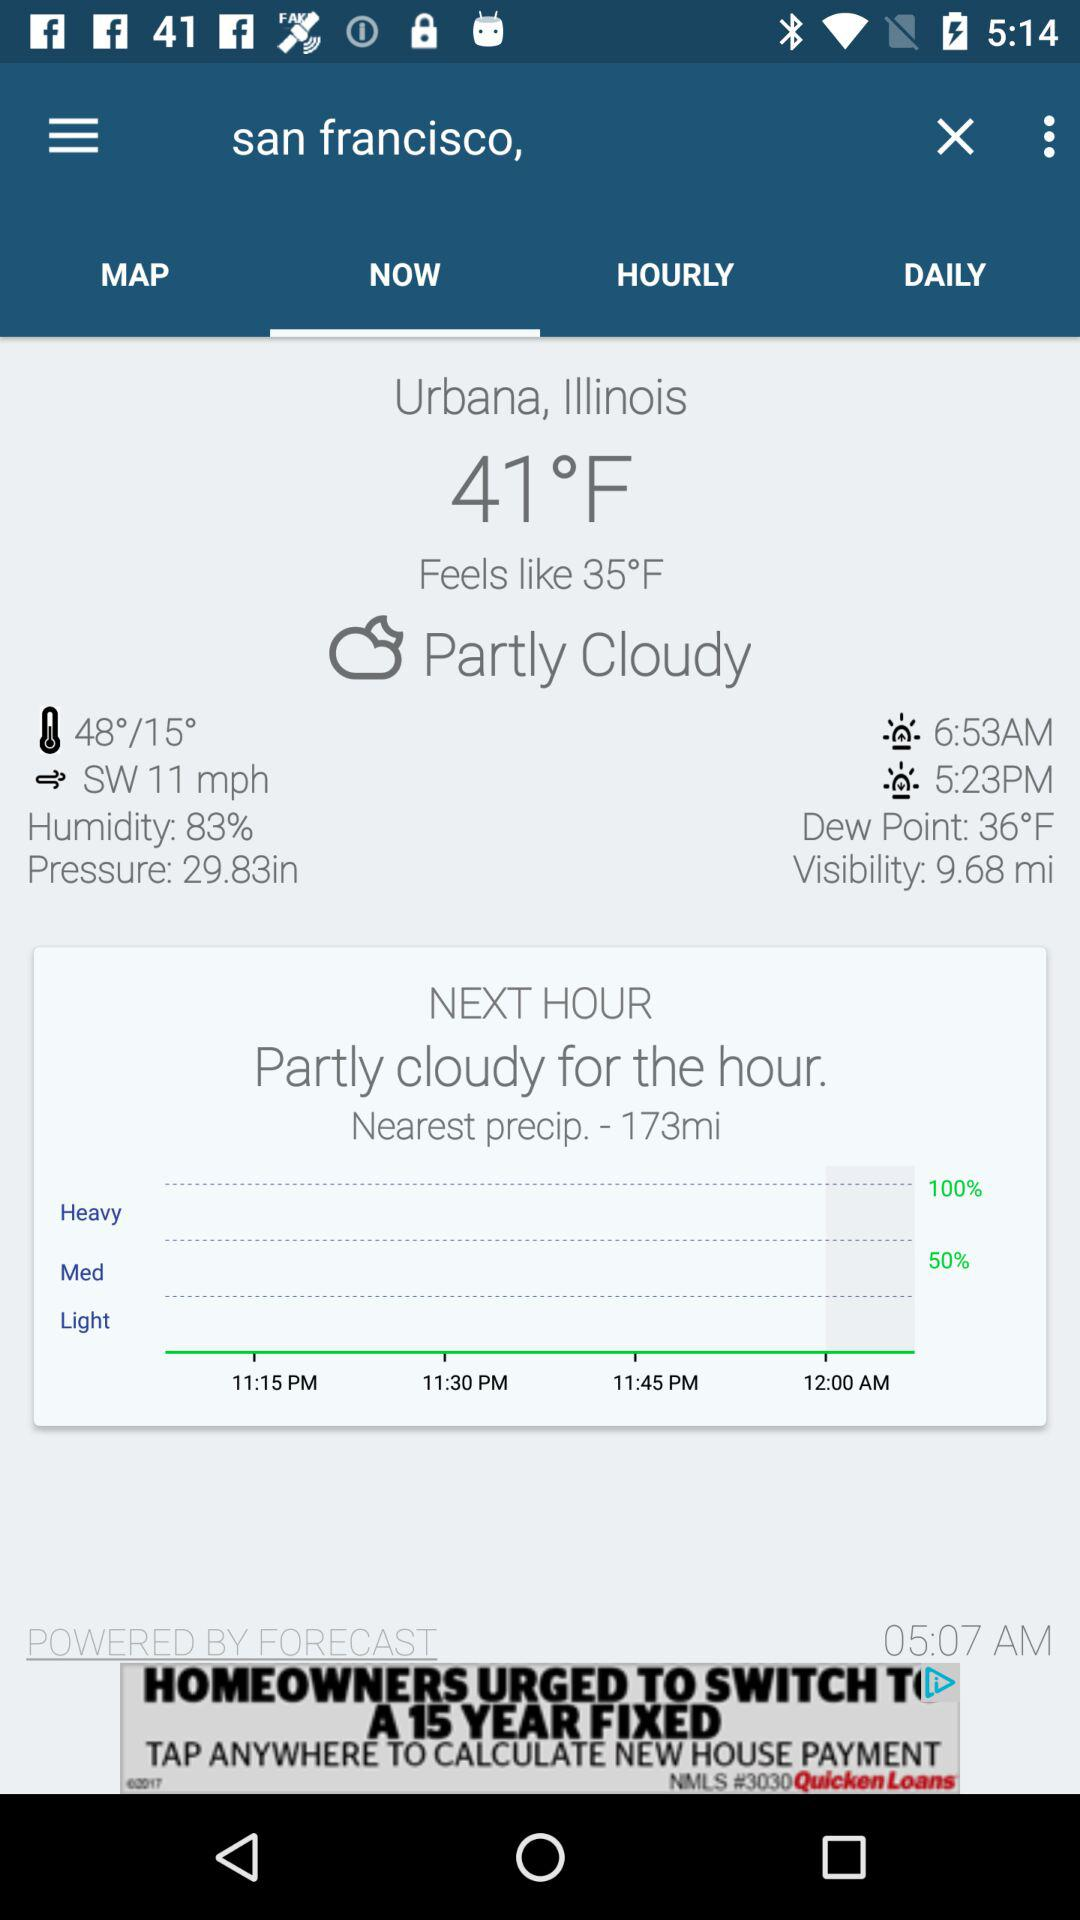What is the difference in temperature between the current and feels like temperatures?
Answer the question using a single word or phrase. 6°F 